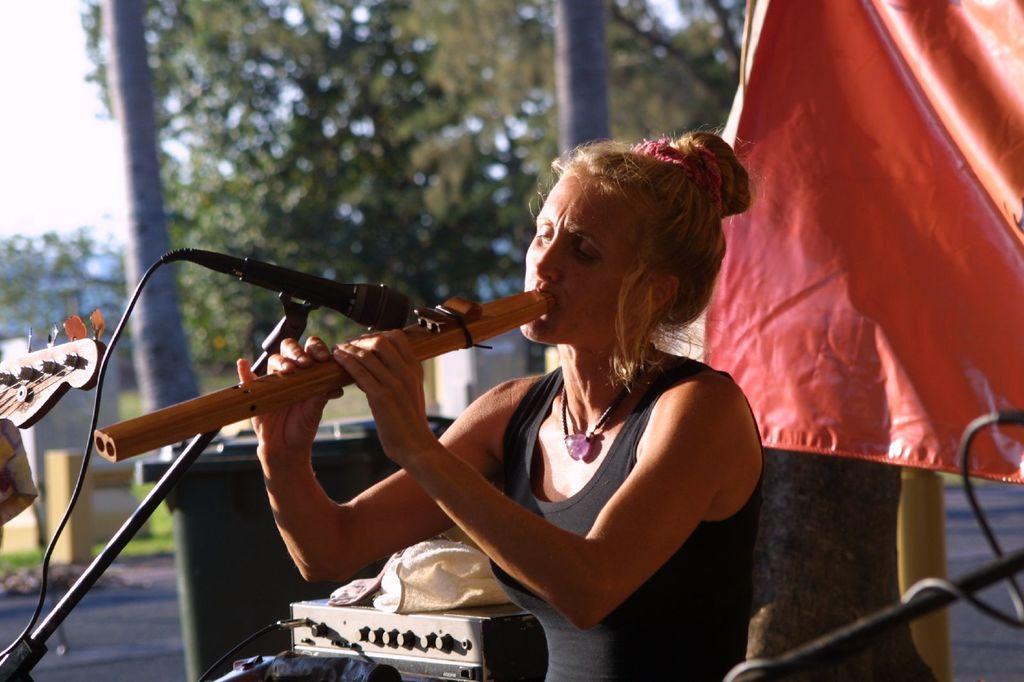Please provide a concise description of this image. In the image we can see there is a woman who is sitting and she is holding a flute. There is a mic in front of her with a stand. At the back there are other musical instruments and there is a red colour cloth. 